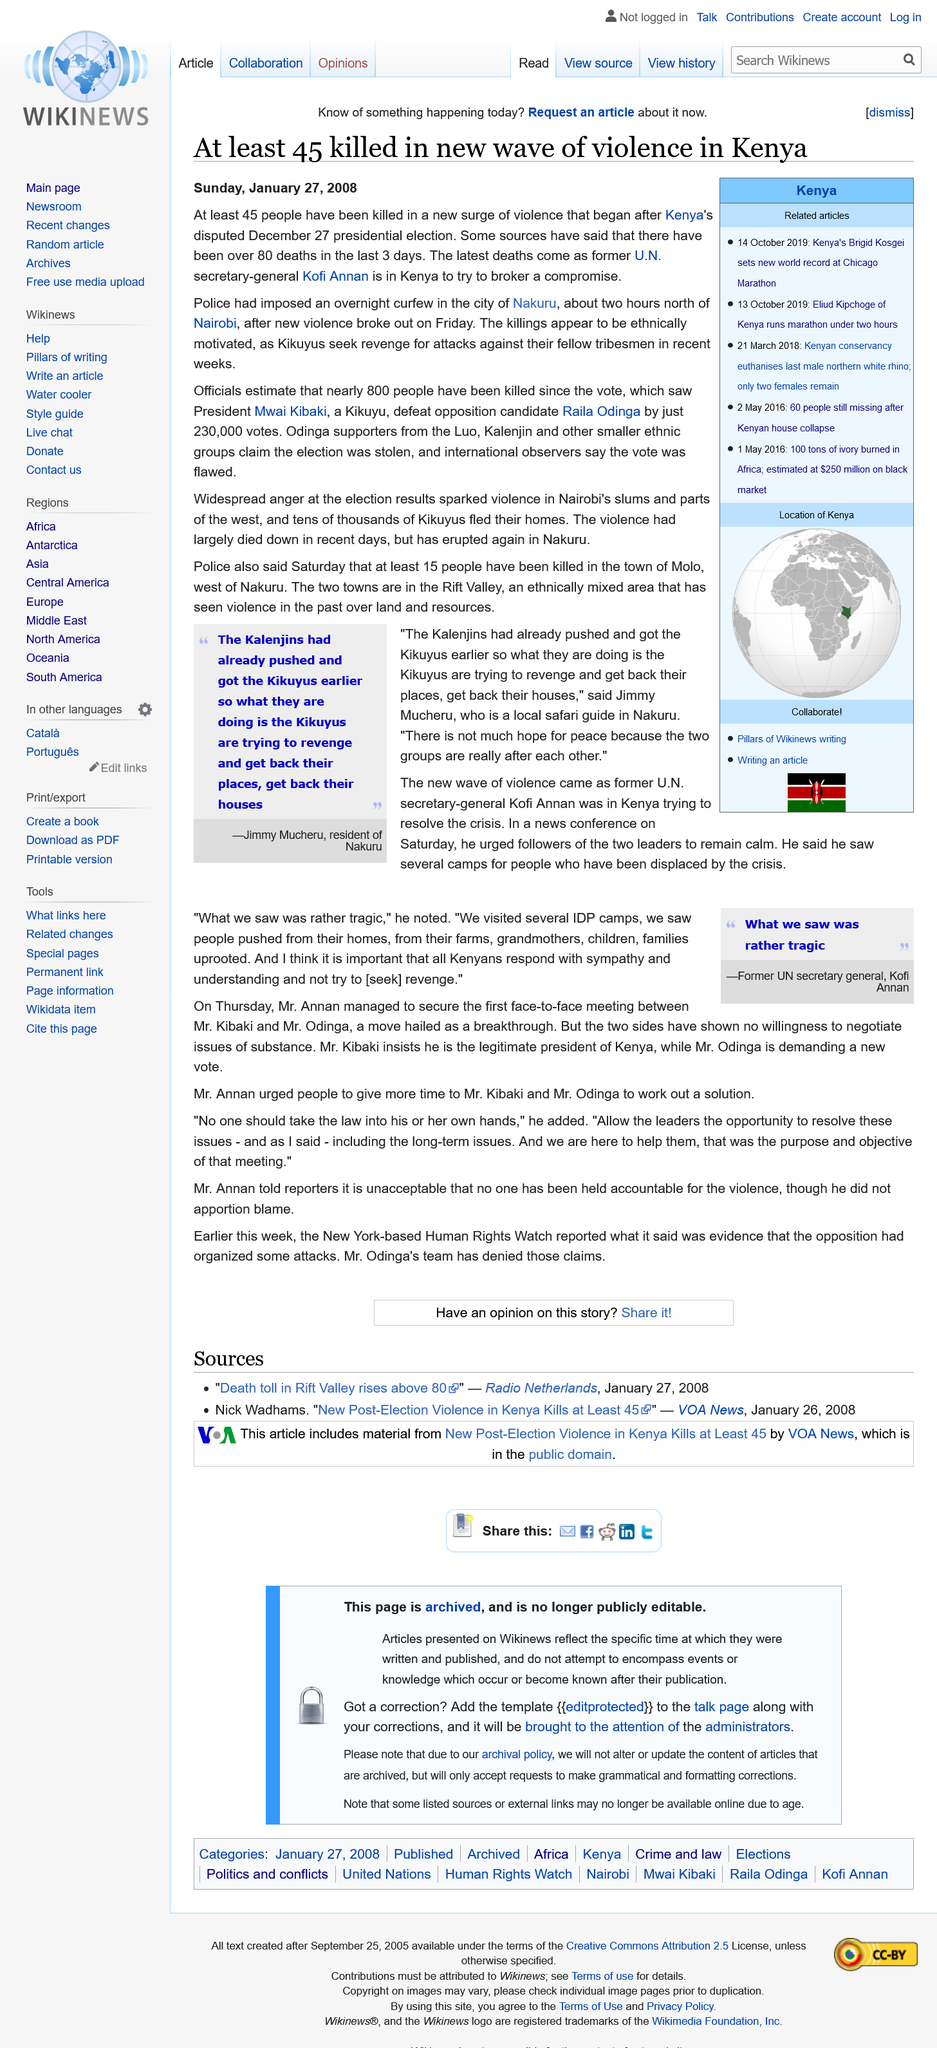Specify some key components in this picture. On Sunday, January 27, 2008, the article on the killing of 45 in a new wave of violence was published. An overnight curfew was imposed in Nakuru. The Kikuyus are seeking revenge. 